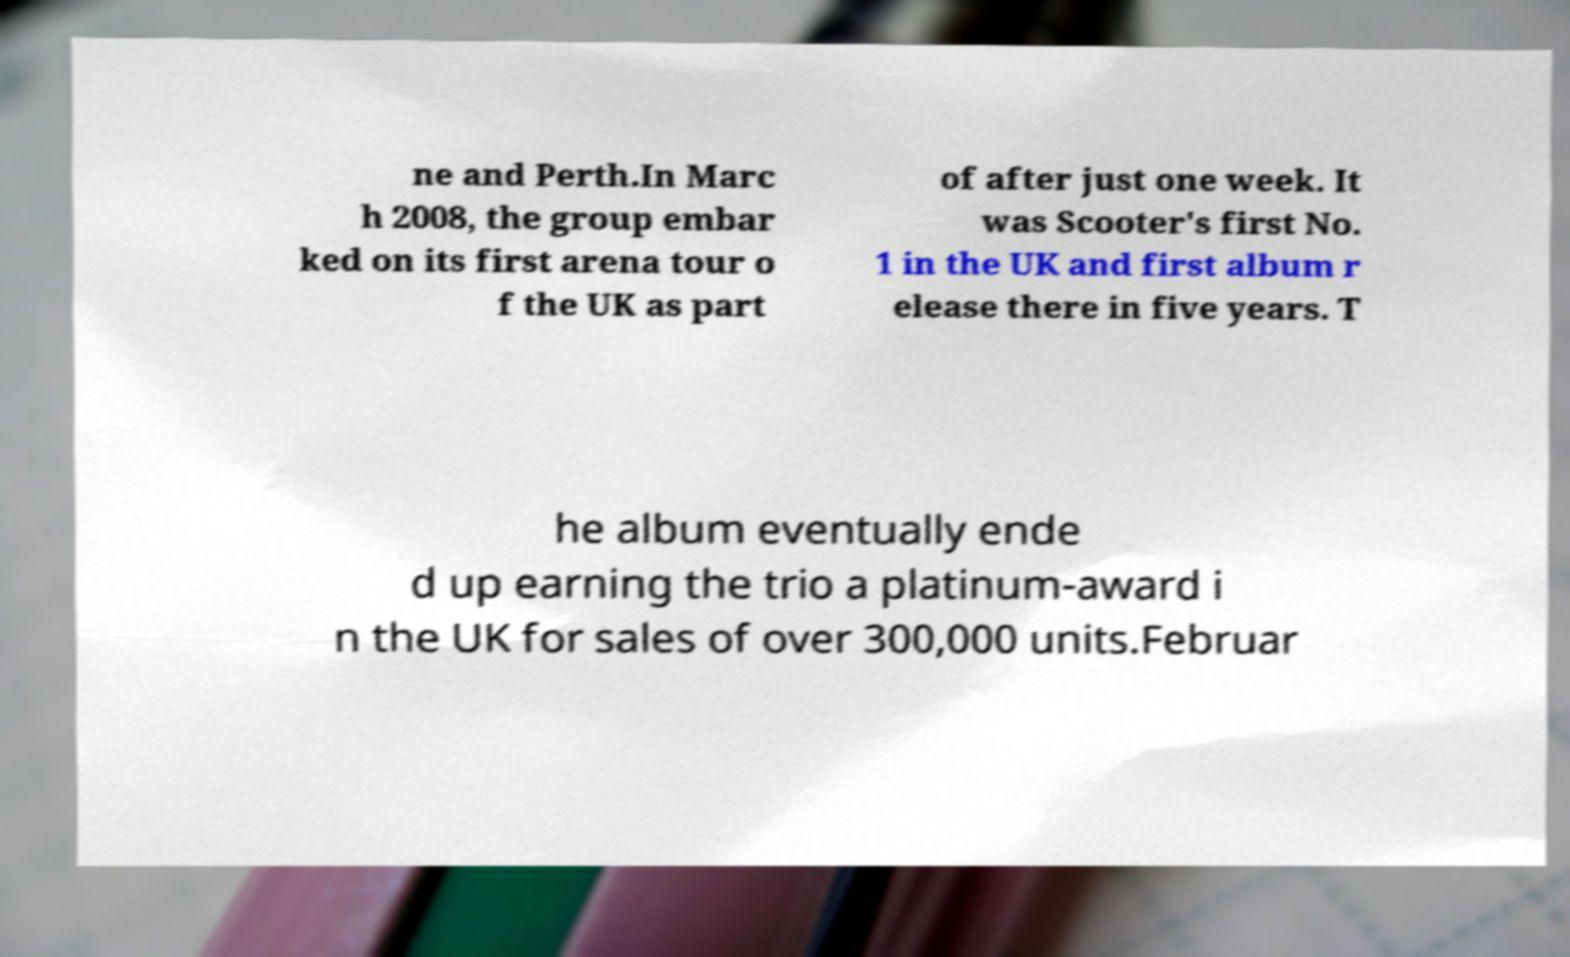Please identify and transcribe the text found in this image. ne and Perth.In Marc h 2008, the group embar ked on its first arena tour o f the UK as part of after just one week. It was Scooter's first No. 1 in the UK and first album r elease there in five years. T he album eventually ende d up earning the trio a platinum-award i n the UK for sales of over 300,000 units.Februar 